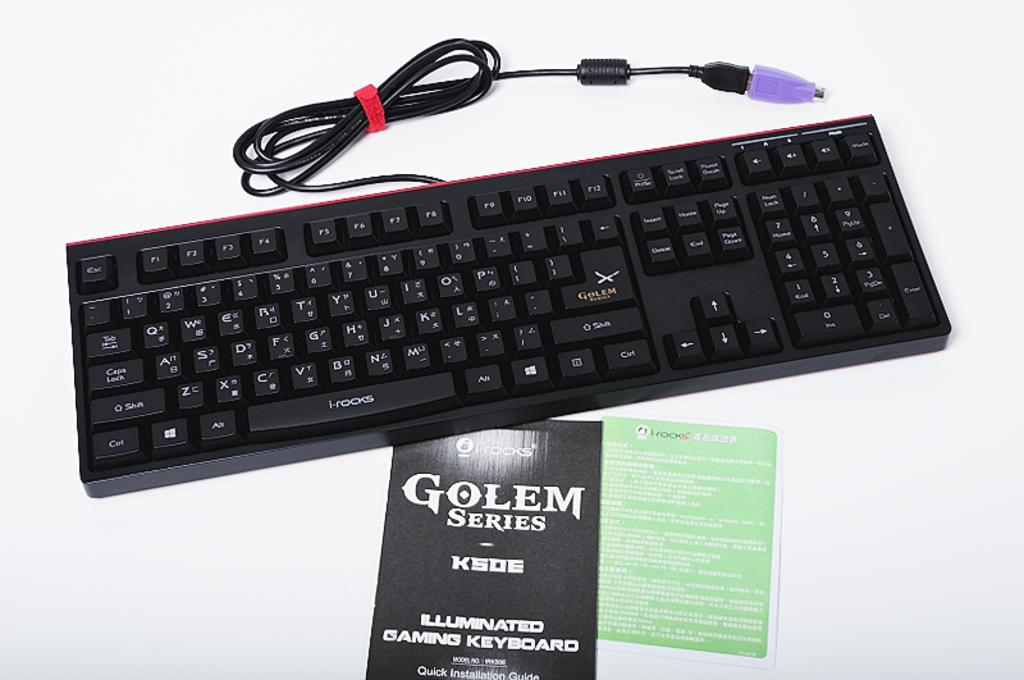<image>
Summarize the visual content of the image. A keyboard sits near a brochure for Golem Series keyboards. 